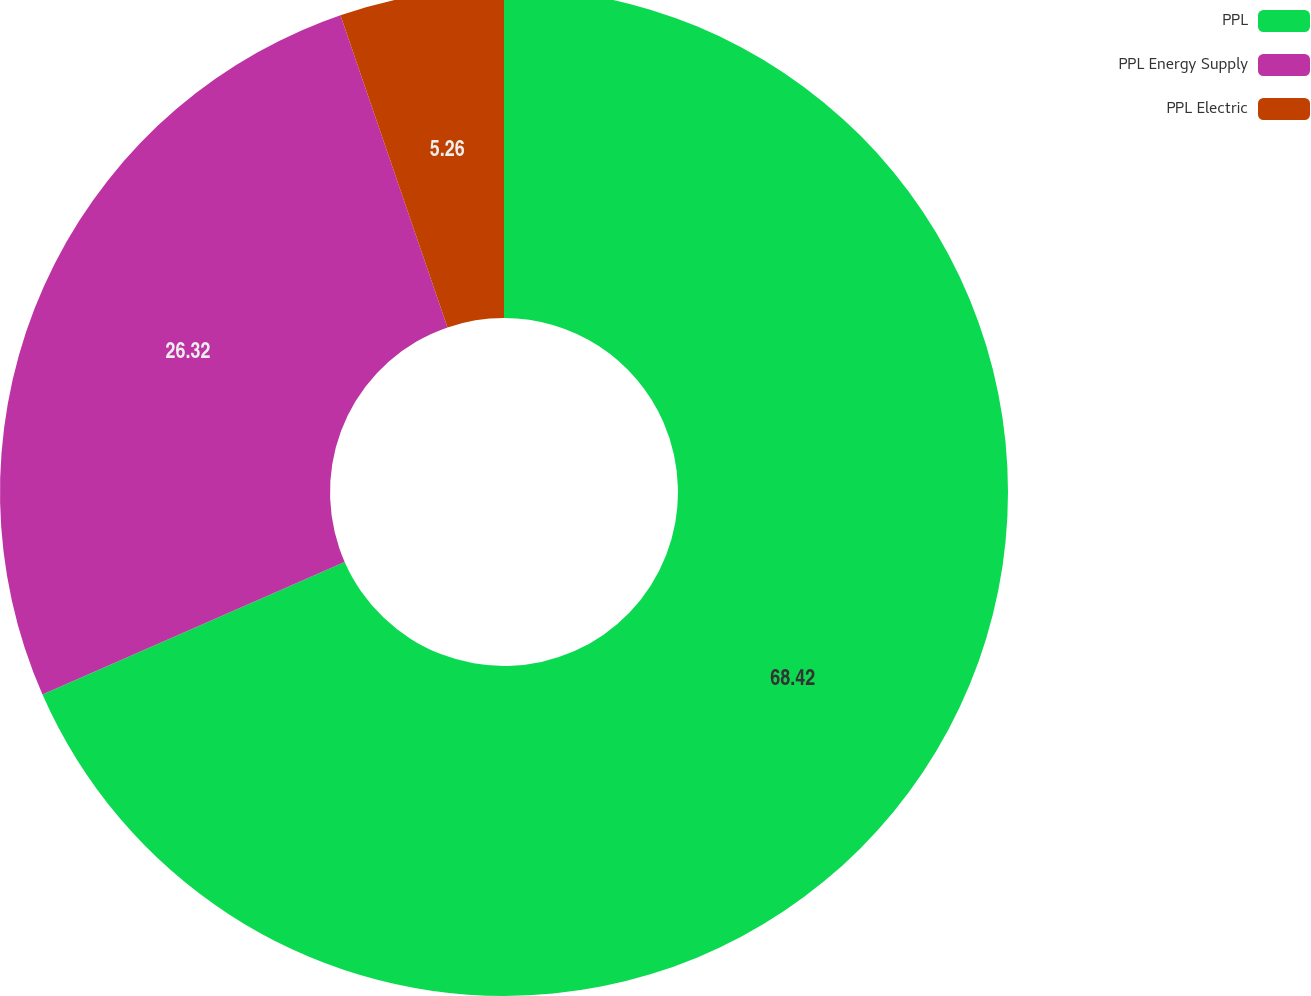<chart> <loc_0><loc_0><loc_500><loc_500><pie_chart><fcel>PPL<fcel>PPL Energy Supply<fcel>PPL Electric<nl><fcel>68.42%<fcel>26.32%<fcel>5.26%<nl></chart> 